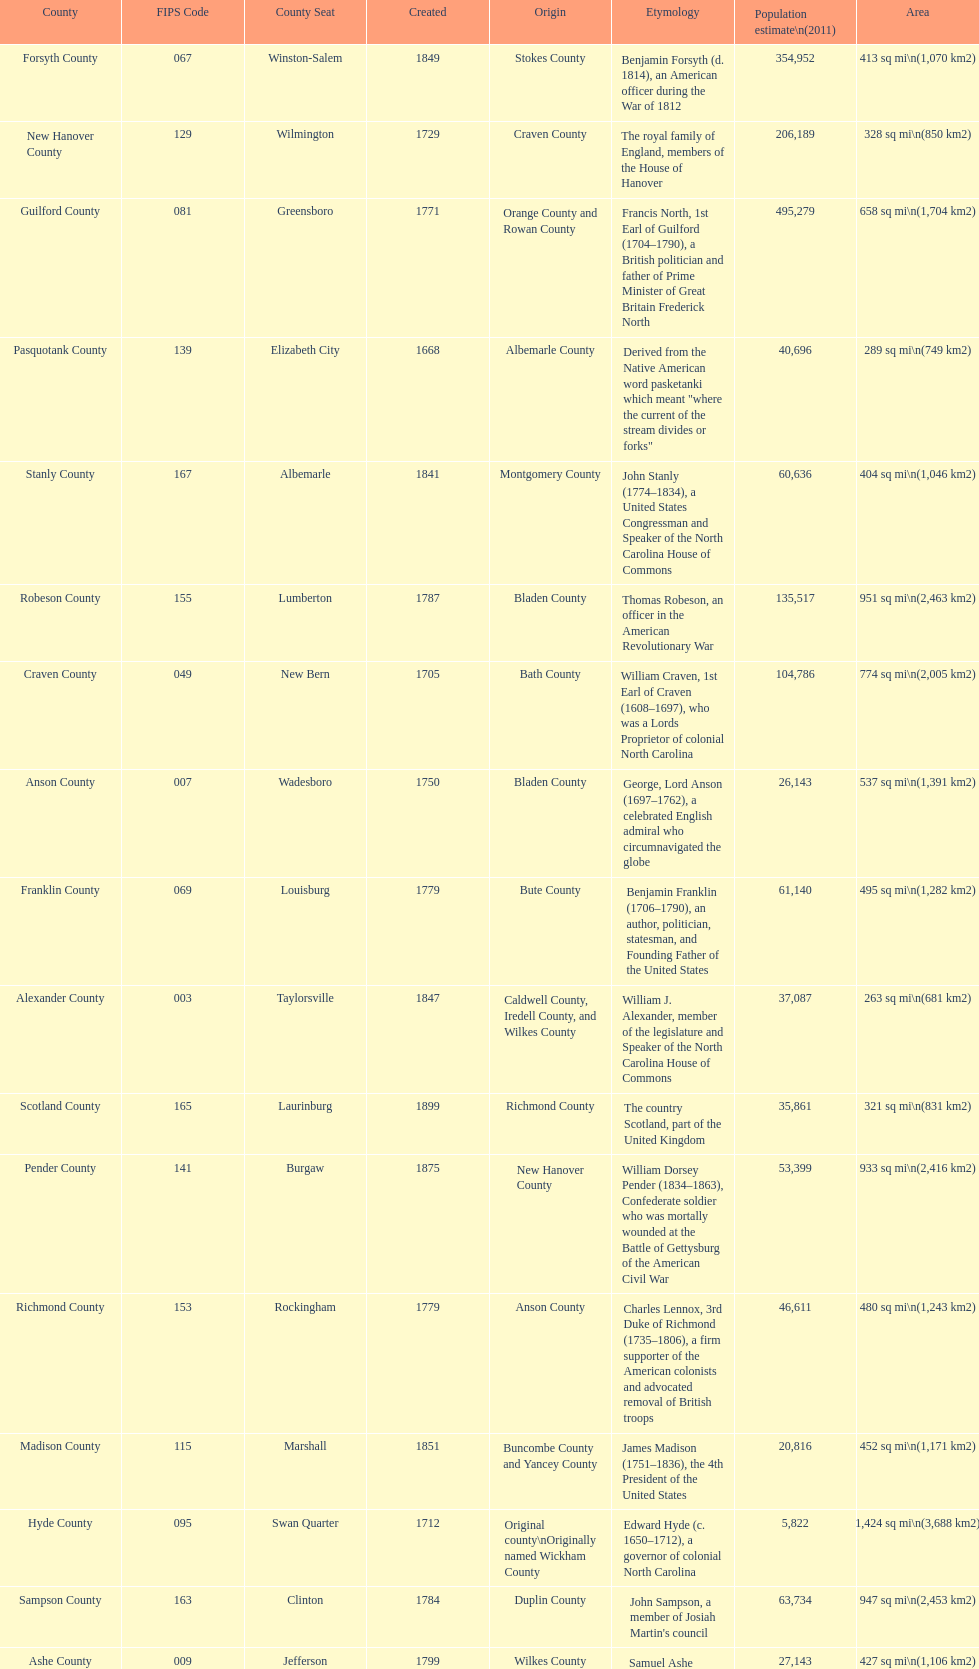Which county has a higher population, alamance or alexander? Alamance County. 